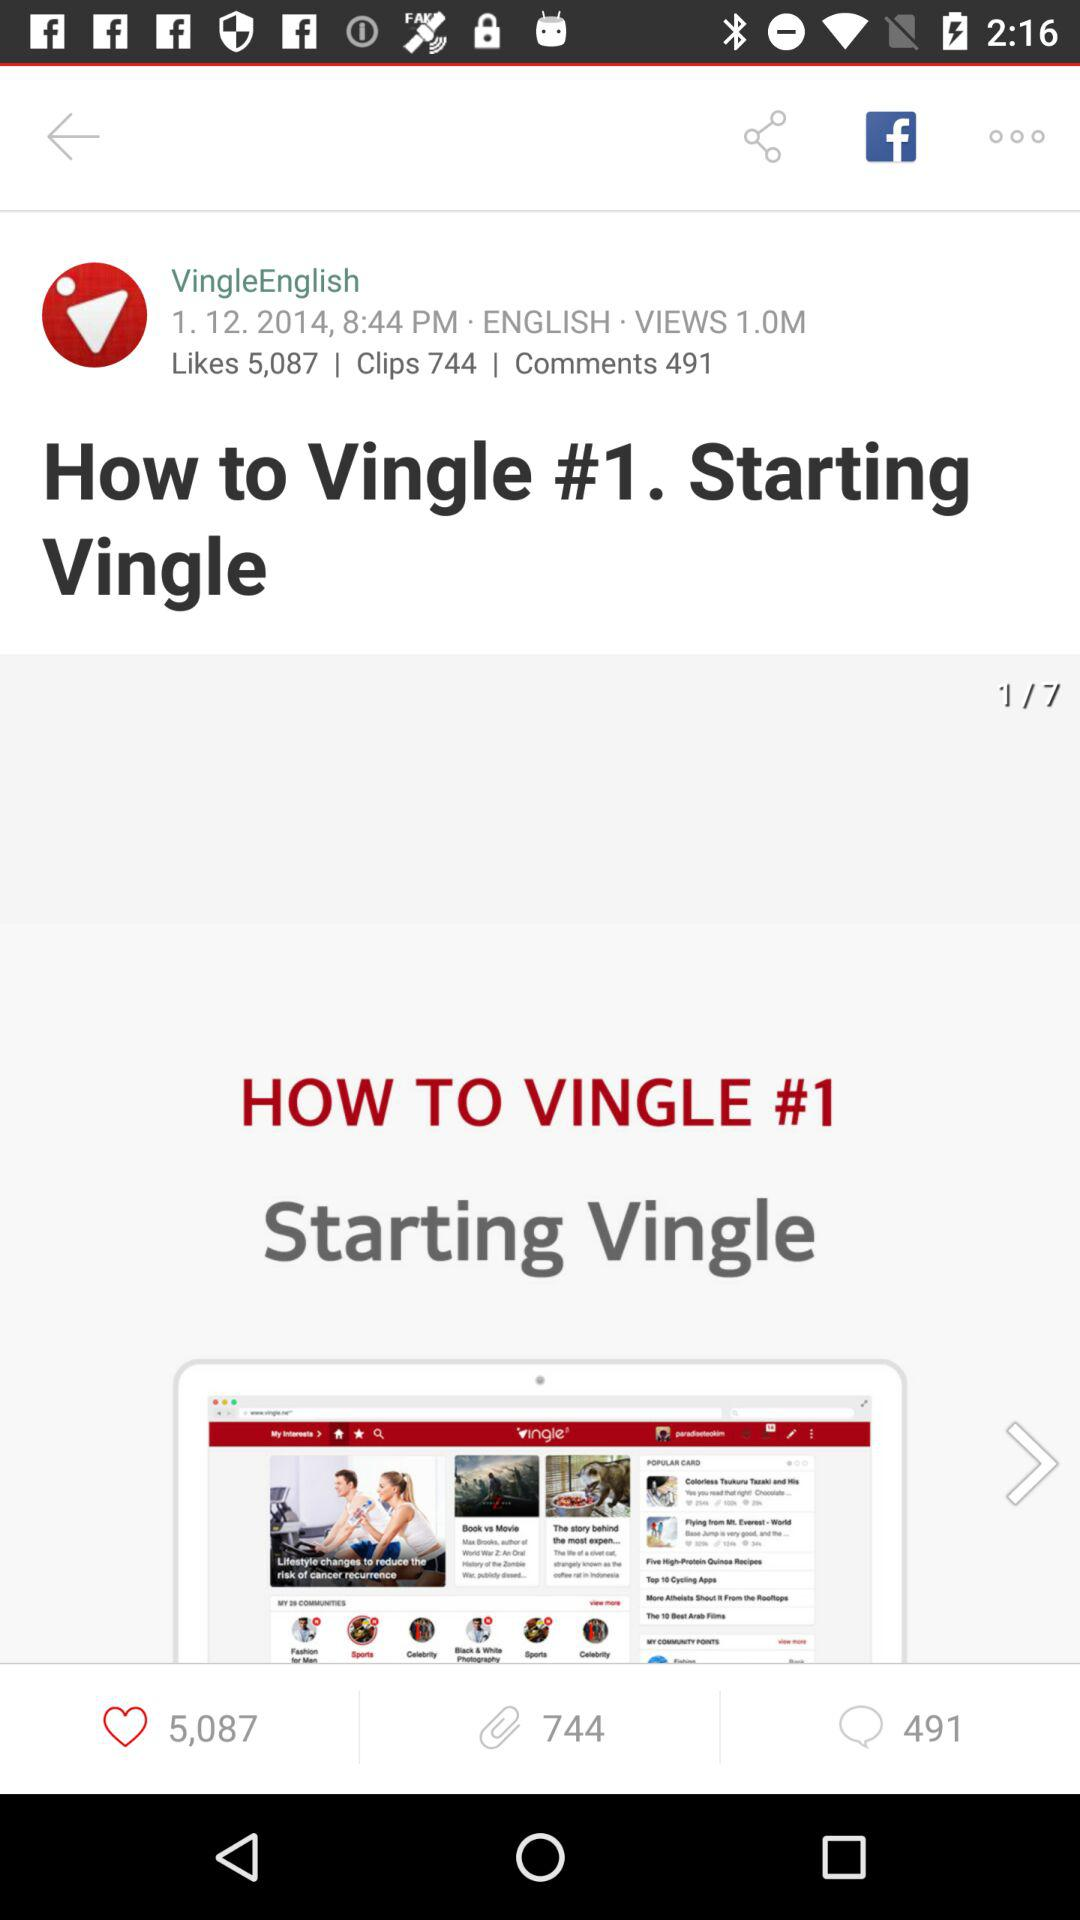How many more likes does the video have than comments?
Answer the question using a single word or phrase. 4596 